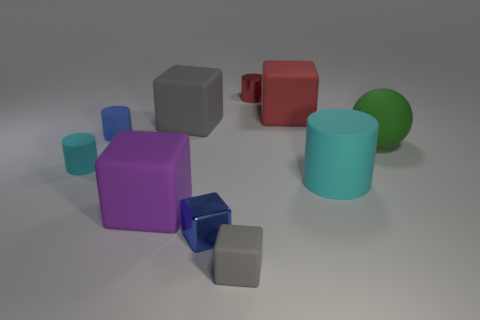Subtract all small matte cubes. How many cubes are left? 4 Subtract all red blocks. How many blocks are left? 4 Subtract all green cylinders. Subtract all cyan cubes. How many cylinders are left? 4 Subtract all cylinders. How many objects are left? 6 Add 1 big matte objects. How many big matte objects exist? 6 Subtract 2 gray cubes. How many objects are left? 8 Subtract all big red objects. Subtract all purple matte blocks. How many objects are left? 8 Add 1 big rubber things. How many big rubber things are left? 6 